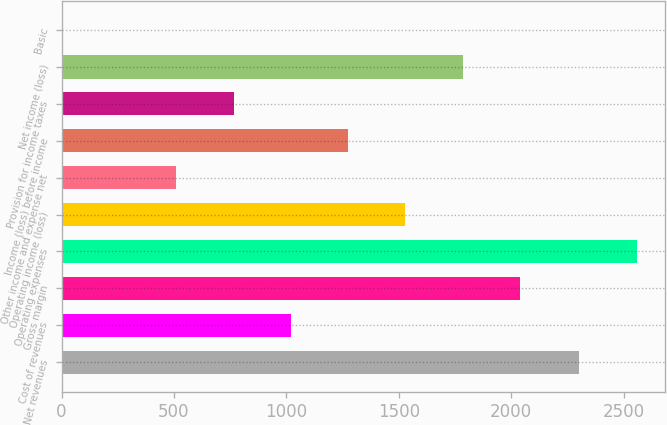Convert chart to OTSL. <chart><loc_0><loc_0><loc_500><loc_500><bar_chart><fcel>Net revenues<fcel>Cost of revenues<fcel>Gross margin<fcel>Operating expenses<fcel>Operating income (loss)<fcel>Other income and expense net<fcel>Income (loss) before income<fcel>Provision for income taxes<fcel>Net income (loss)<fcel>Basic<nl><fcel>2303.6<fcel>1019.88<fcel>2038<fcel>2558.13<fcel>1528.94<fcel>510.82<fcel>1274.41<fcel>765.35<fcel>1783.47<fcel>1.76<nl></chart> 